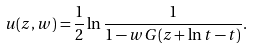<formula> <loc_0><loc_0><loc_500><loc_500>u ( z , w ) = \frac { 1 } { 2 } \ln \frac { 1 } { 1 - w G ( z + \ln t - t ) } .</formula> 